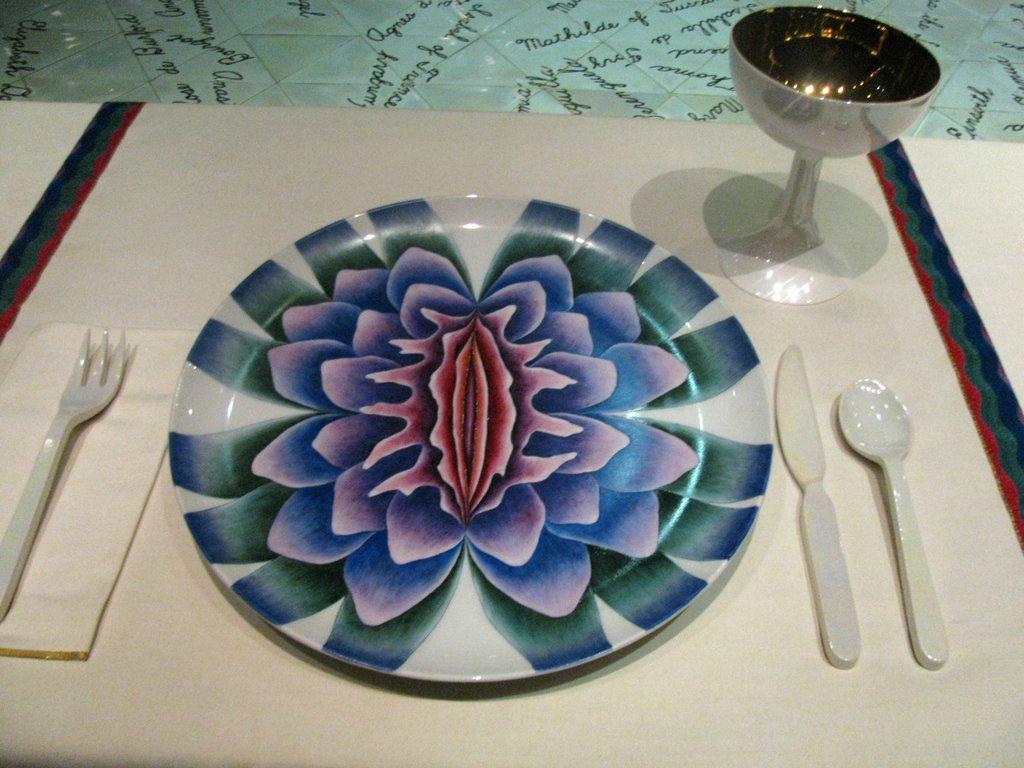Describe this image in one or two sentences. In the given image we can see that, there is a plate, spoon, knife, fork and a glass. 